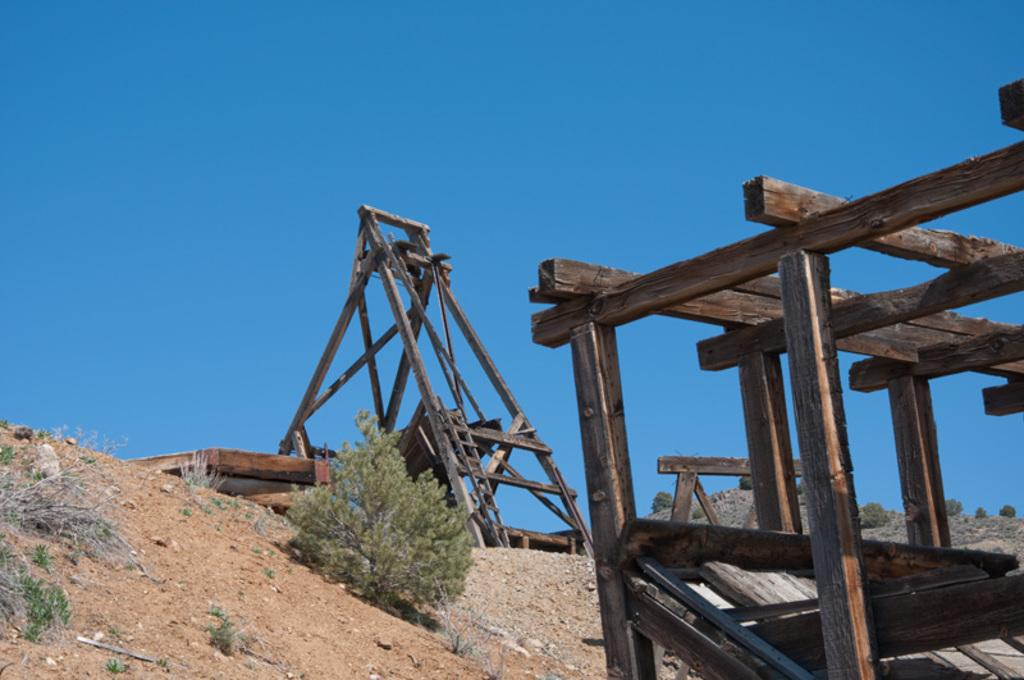What is located in the foreground of the image? There is a wooden structure in the foreground of the image. What can be seen in the background of the image? There is a plant, sand, a trebuchet, and the sky visible in the background of the image. Can you describe the type of plant in the background? The provided facts do not specify the type of plant in the background. What is the condition of the sky in the image? The sky is visible in the background of the image. What type of wound can be seen on the trebuchet in the image? There is no wound present on the trebuchet in the image. What time of day is it in the image, given the presence of morning light? The provided facts do not mention the time of day or any specific lighting conditions in the image. 